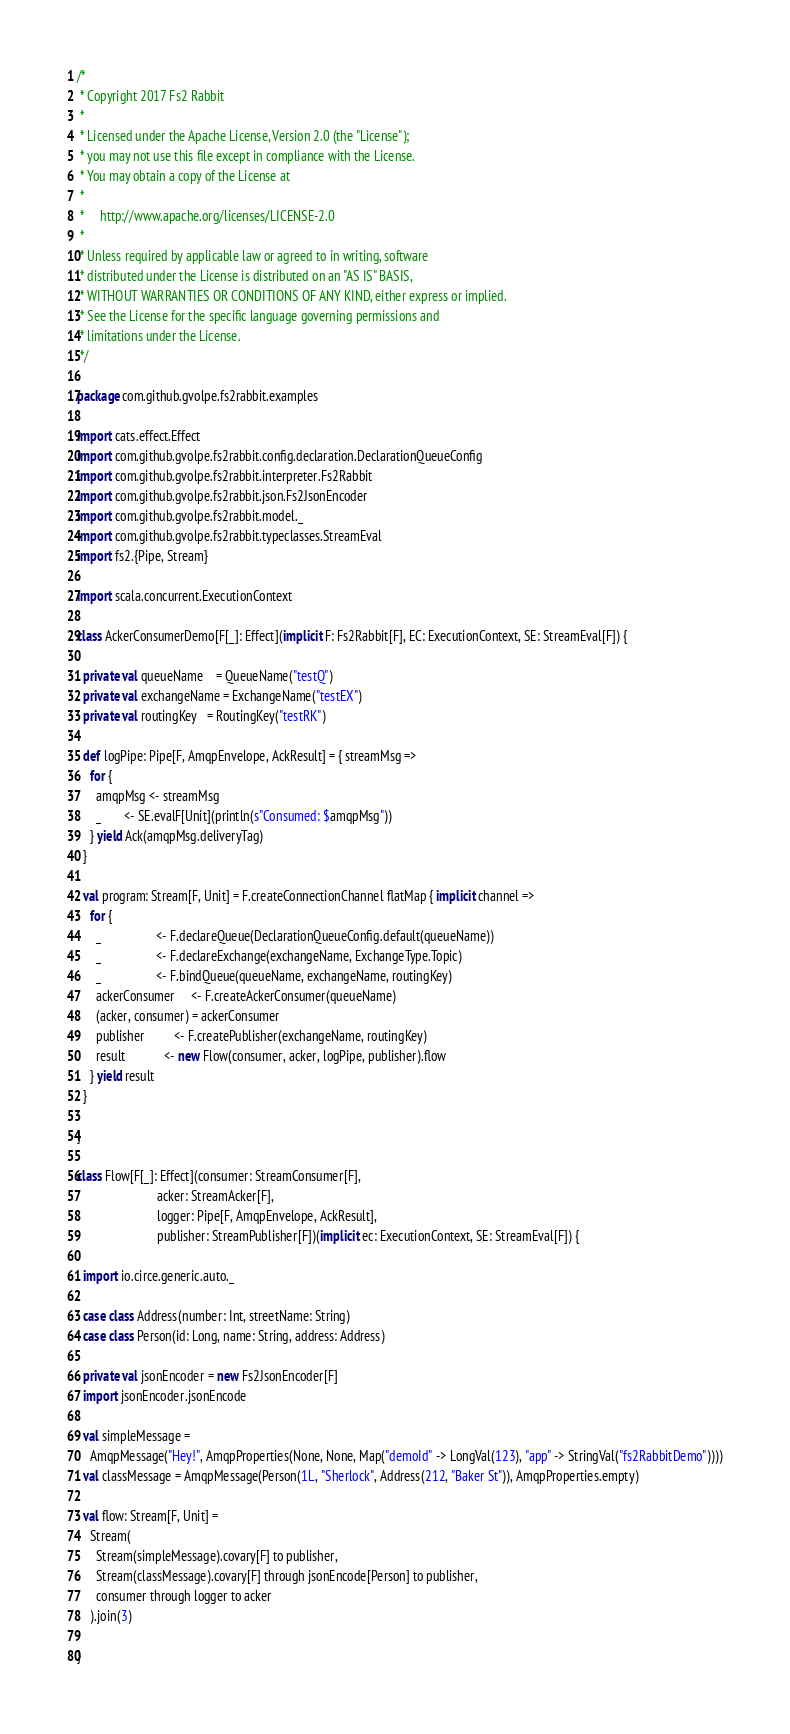<code> <loc_0><loc_0><loc_500><loc_500><_Scala_>/*
 * Copyright 2017 Fs2 Rabbit
 *
 * Licensed under the Apache License, Version 2.0 (the "License");
 * you may not use this file except in compliance with the License.
 * You may obtain a copy of the License at
 *
 *     http://www.apache.org/licenses/LICENSE-2.0
 *
 * Unless required by applicable law or agreed to in writing, software
 * distributed under the License is distributed on an "AS IS" BASIS,
 * WITHOUT WARRANTIES OR CONDITIONS OF ANY KIND, either express or implied.
 * See the License for the specific language governing permissions and
 * limitations under the License.
 */

package com.github.gvolpe.fs2rabbit.examples

import cats.effect.Effect
import com.github.gvolpe.fs2rabbit.config.declaration.DeclarationQueueConfig
import com.github.gvolpe.fs2rabbit.interpreter.Fs2Rabbit
import com.github.gvolpe.fs2rabbit.json.Fs2JsonEncoder
import com.github.gvolpe.fs2rabbit.model._
import com.github.gvolpe.fs2rabbit.typeclasses.StreamEval
import fs2.{Pipe, Stream}

import scala.concurrent.ExecutionContext

class AckerConsumerDemo[F[_]: Effect](implicit F: Fs2Rabbit[F], EC: ExecutionContext, SE: StreamEval[F]) {

  private val queueName    = QueueName("testQ")
  private val exchangeName = ExchangeName("testEX")
  private val routingKey   = RoutingKey("testRK")

  def logPipe: Pipe[F, AmqpEnvelope, AckResult] = { streamMsg =>
    for {
      amqpMsg <- streamMsg
      _       <- SE.evalF[Unit](println(s"Consumed: $amqpMsg"))
    } yield Ack(amqpMsg.deliveryTag)
  }

  val program: Stream[F, Unit] = F.createConnectionChannel flatMap { implicit channel =>
    for {
      _                 <- F.declareQueue(DeclarationQueueConfig.default(queueName))
      _                 <- F.declareExchange(exchangeName, ExchangeType.Topic)
      _                 <- F.bindQueue(queueName, exchangeName, routingKey)
      ackerConsumer     <- F.createAckerConsumer(queueName)
      (acker, consumer) = ackerConsumer
      publisher         <- F.createPublisher(exchangeName, routingKey)
      result            <- new Flow(consumer, acker, logPipe, publisher).flow
    } yield result
  }

}

class Flow[F[_]: Effect](consumer: StreamConsumer[F],
                         acker: StreamAcker[F],
                         logger: Pipe[F, AmqpEnvelope, AckResult],
                         publisher: StreamPublisher[F])(implicit ec: ExecutionContext, SE: StreamEval[F]) {

  import io.circe.generic.auto._

  case class Address(number: Int, streetName: String)
  case class Person(id: Long, name: String, address: Address)

  private val jsonEncoder = new Fs2JsonEncoder[F]
  import jsonEncoder.jsonEncode

  val simpleMessage =
    AmqpMessage("Hey!", AmqpProperties(None, None, Map("demoId" -> LongVal(123), "app" -> StringVal("fs2RabbitDemo"))))
  val classMessage = AmqpMessage(Person(1L, "Sherlock", Address(212, "Baker St")), AmqpProperties.empty)

  val flow: Stream[F, Unit] =
    Stream(
      Stream(simpleMessage).covary[F] to publisher,
      Stream(classMessage).covary[F] through jsonEncode[Person] to publisher,
      consumer through logger to acker
    ).join(3)

}
</code> 